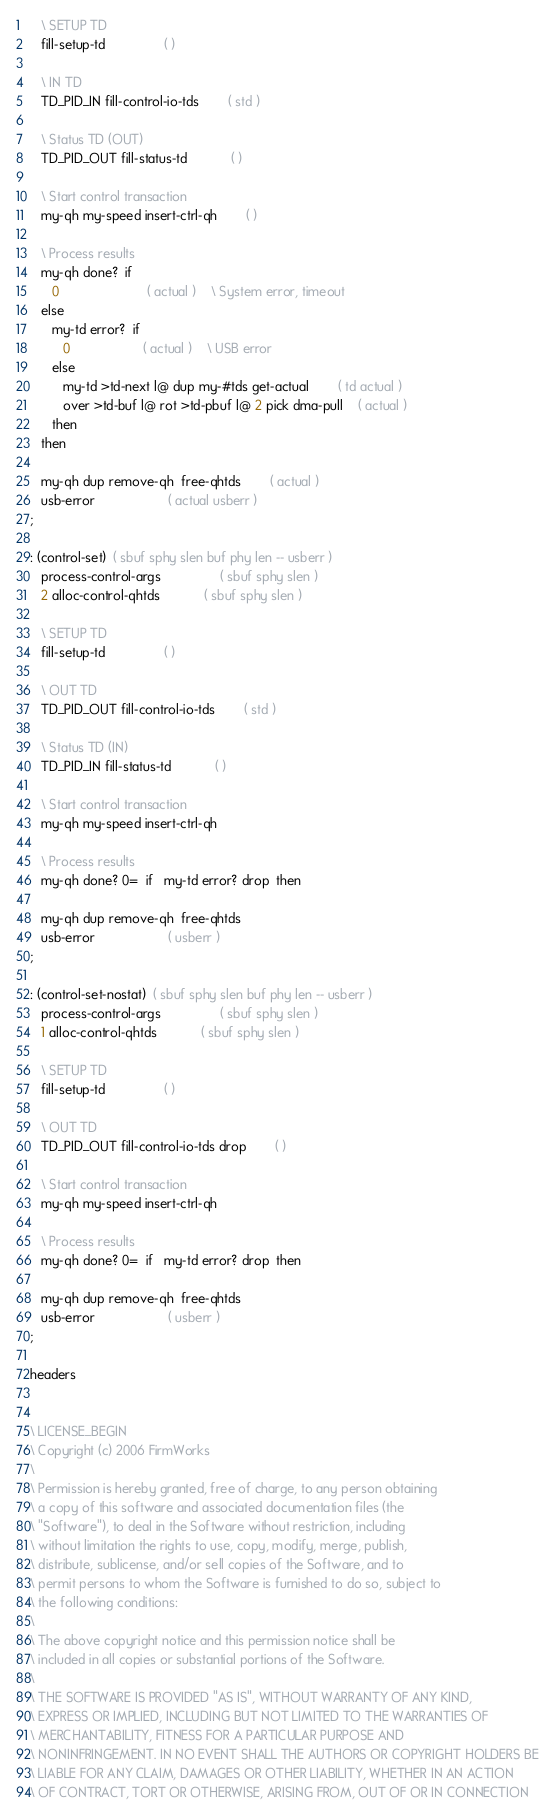Convert code to text. <code><loc_0><loc_0><loc_500><loc_500><_Forth_>
   \ SETUP TD
   fill-setup-td				( )

   \ IN TD
   TD_PID_IN fill-control-io-tds		( std )

   \ Status TD (OUT)
   TD_PID_OUT fill-status-td			( )

   \ Start control transaction
   my-qh my-speed insert-ctrl-qh		( )

   \ Process results
   my-qh done?  if
      0						( actual )	\ System error, timeout
   else
      my-td error?  if
         0					( actual )	\ USB error
      else
         my-td >td-next l@ dup my-#tds get-actual		( td actual )
         over >td-buf l@ rot >td-pbuf l@ 2 pick dma-pull	( actual )
      then
   then

   my-qh dup remove-qh  free-qhtds		( actual )
   usb-error					( actual usberr )
;

: (control-set)  ( sbuf sphy slen buf phy len -- usberr )
   process-control-args				( sbuf sphy slen )
   2 alloc-control-qhtds			( sbuf sphy slen )

   \ SETUP TD
   fill-setup-td				( )

   \ OUT TD
   TD_PID_OUT fill-control-io-tds		( std )

   \ Status TD (IN)
   TD_PID_IN fill-status-td			( )

   \ Start control transaction
   my-qh my-speed insert-ctrl-qh

   \ Process results
   my-qh done? 0=  if   my-td error? drop  then

   my-qh dup remove-qh  free-qhtds
   usb-error					( usberr )
;

: (control-set-nostat)  ( sbuf sphy slen buf phy len -- usberr )
   process-control-args				( sbuf sphy slen )
   1 alloc-control-qhtds			( sbuf sphy slen )

   \ SETUP TD
   fill-setup-td				( )

   \ OUT TD
   TD_PID_OUT fill-control-io-tds drop		( )

   \ Start control transaction
   my-qh my-speed insert-ctrl-qh

   \ Process results
   my-qh done? 0=  if   my-td error? drop  then

   my-qh dup remove-qh  free-qhtds
   usb-error					( usberr )
;

headers


\ LICENSE_BEGIN
\ Copyright (c) 2006 FirmWorks
\ 
\ Permission is hereby granted, free of charge, to any person obtaining
\ a copy of this software and associated documentation files (the
\ "Software"), to deal in the Software without restriction, including
\ without limitation the rights to use, copy, modify, merge, publish,
\ distribute, sublicense, and/or sell copies of the Software, and to
\ permit persons to whom the Software is furnished to do so, subject to
\ the following conditions:
\ 
\ The above copyright notice and this permission notice shall be
\ included in all copies or substantial portions of the Software.
\ 
\ THE SOFTWARE IS PROVIDED "AS IS", WITHOUT WARRANTY OF ANY KIND,
\ EXPRESS OR IMPLIED, INCLUDING BUT NOT LIMITED TO THE WARRANTIES OF
\ MERCHANTABILITY, FITNESS FOR A PARTICULAR PURPOSE AND
\ NONINFRINGEMENT. IN NO EVENT SHALL THE AUTHORS OR COPYRIGHT HOLDERS BE
\ LIABLE FOR ANY CLAIM, DAMAGES OR OTHER LIABILITY, WHETHER IN AN ACTION
\ OF CONTRACT, TORT OR OTHERWISE, ARISING FROM, OUT OF OR IN CONNECTION</code> 